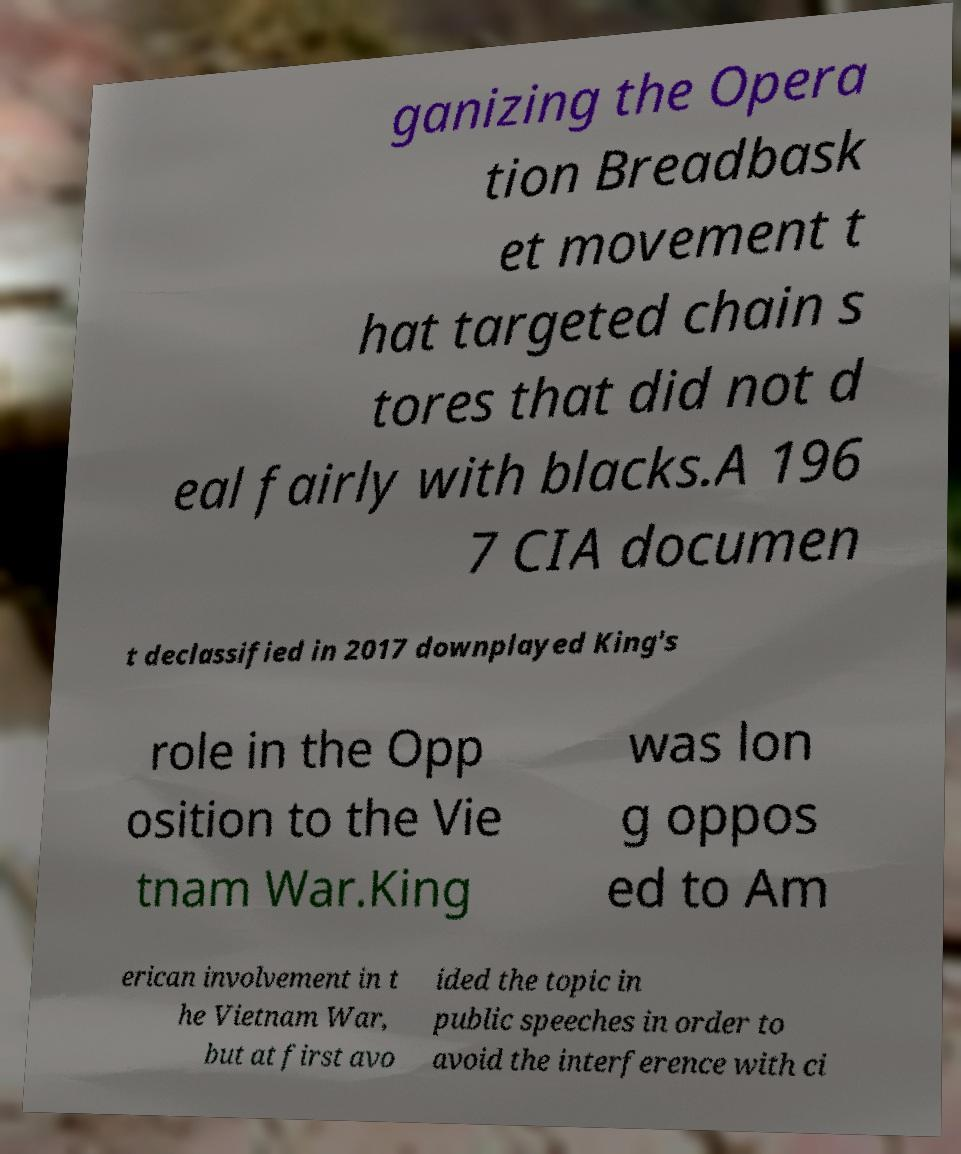Could you assist in decoding the text presented in this image and type it out clearly? ganizing the Opera tion Breadbask et movement t hat targeted chain s tores that did not d eal fairly with blacks.A 196 7 CIA documen t declassified in 2017 downplayed King's role in the Opp osition to the Vie tnam War.King was lon g oppos ed to Am erican involvement in t he Vietnam War, but at first avo ided the topic in public speeches in order to avoid the interference with ci 